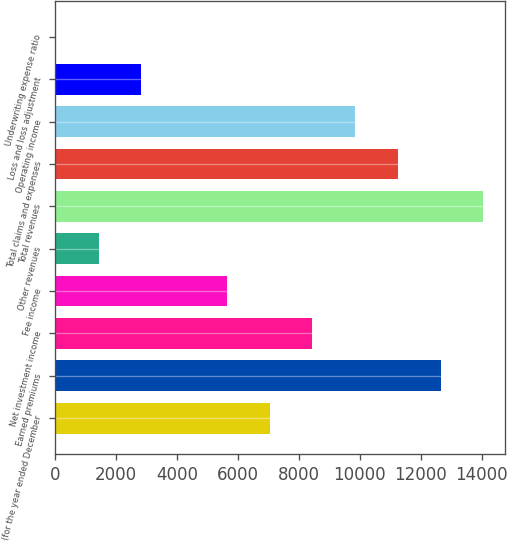Convert chart. <chart><loc_0><loc_0><loc_500><loc_500><bar_chart><fcel>(for the year ended December<fcel>Earned premiums<fcel>Net investment income<fcel>Fee income<fcel>Other revenues<fcel>Total revenues<fcel>Total claims and expenses<fcel>Operating income<fcel>Loss and loss adjustment<fcel>Underwriting expense ratio<nl><fcel>7039.8<fcel>12647.2<fcel>8441.64<fcel>5637.96<fcel>1432.44<fcel>14049<fcel>11245.3<fcel>9843.48<fcel>2834.28<fcel>30.6<nl></chart> 